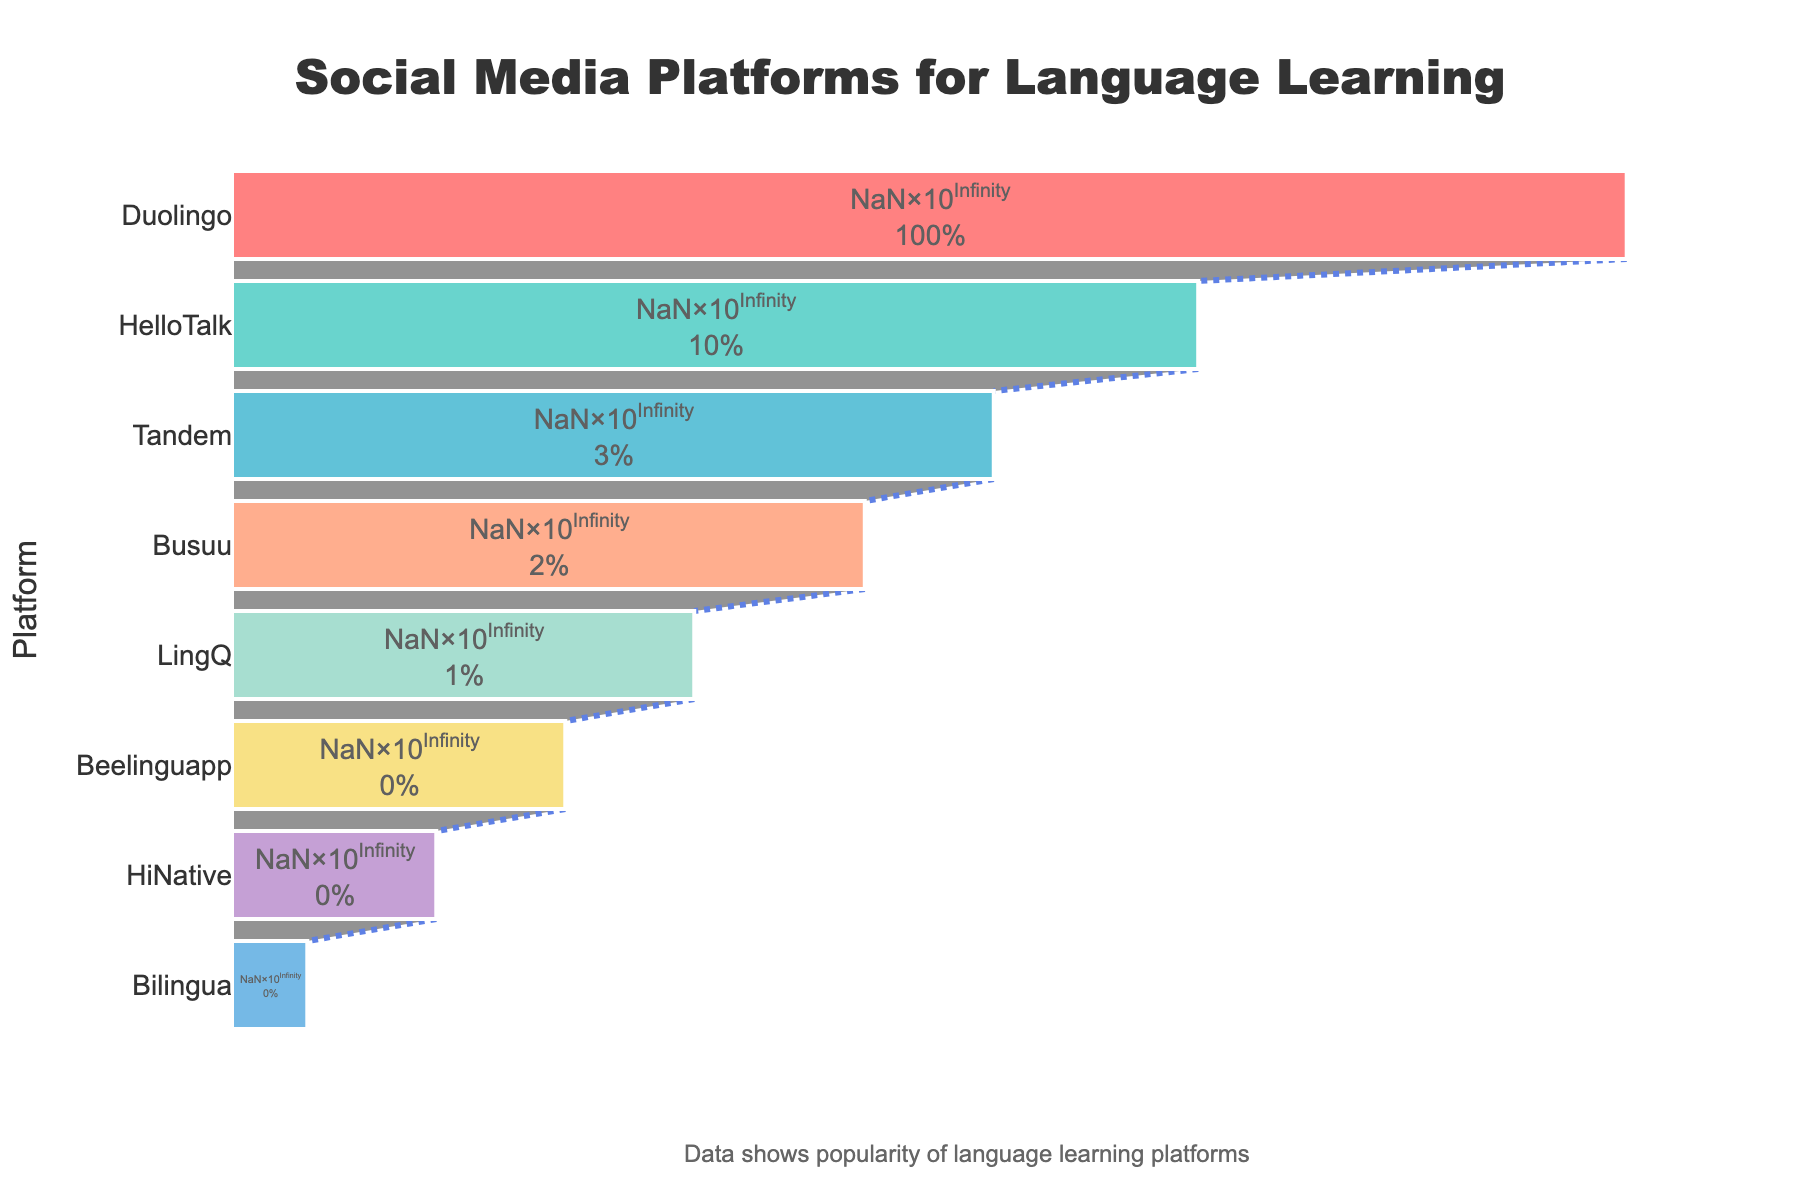What is the title of the funnel chart? The title of the funnel chart is found at the top center and is often the largest and most prominent text on the chart. The title reads "Social Media Platforms for Language Learning".
Answer: Social Media Platforms for Language Learning Which platform has the highest number of users? The platform with the highest number of users is at the top of the funnel chart, as it represents the widest section. This platform is Duolingo.
Answer: Duolingo What is the percentage of users for HelloTalk relative to the total users of Duolingo? To find this percentage, you need to divide the number of users of HelloTalk by the number of users of Duolingo and then multiply by 100. This can be calculated as (30000000 / 300000000) * 100 = 10%.
Answer: 10% How many platforms have fewer than 10 million users? From the funnel chart, observe the number of platforms listed below 10 million users. These platforms are Busuu, LingQ, Beelinguapp, HiNative, and Bilingua, totalling 5 platforms.
Answer: 5 What is the combined user base of Tandem and Beelinguapp? Add the number of users for Tandem and Beelinguapp. Tandem has 10 million users and Beelinguapp has 1 million users, so the combined user base is 10,000,000 + 1,000,000 = 11 million users.
Answer: 11 million Which platform has the second lowest number of users? The platform with the second lowest number of users is right above the smallest section at the bottom of the funnel chart. This platform is HiNative.
Answer: HiNative How much larger is Duolingo's user base compared to Busuu's? Subtract Busuu’s user base from Duolingo’s user base. Duolingo has 300 million users, and Busuu has 5 million. 300,000,000 - 5,000,000 = 295 million users difference.
Answer: 295 million What is the median number of users among all the platforms? To find the median, sort the number of users and locate the middle value. The sorted user counts are 250,000, 500,000, 1,000,000, 2,000,000, 5,000,000, 10,000,000, 30,000,000, 300,000,000. With 8 data points, the median will be the average of the 4th and 5th values: (2,000,000 + 5,000,000) / 2 = 3,500,000.
Answer: 3,500,000 What percentage of the total users do the top three platforms constitute? Add the users of the top three platforms and then divide by the total users of all platforms, multiplying by 100 for the percentage. The top three platforms are Duolingo (300M), HelloTalk (30M), Tandem (10M). Total users = 300M + 30M + 10M = 340M. Total across all platforms is 348.75M. So, (340M / 348.75M) * 100 ≈ 97.49%.
Answer: 97.49% Which color represents the smallest section of the funnel chart? The color coding for the platforms is visible in the chart. The smallest section, representing Bilingua, is colored light blue.
Answer: Light blue 